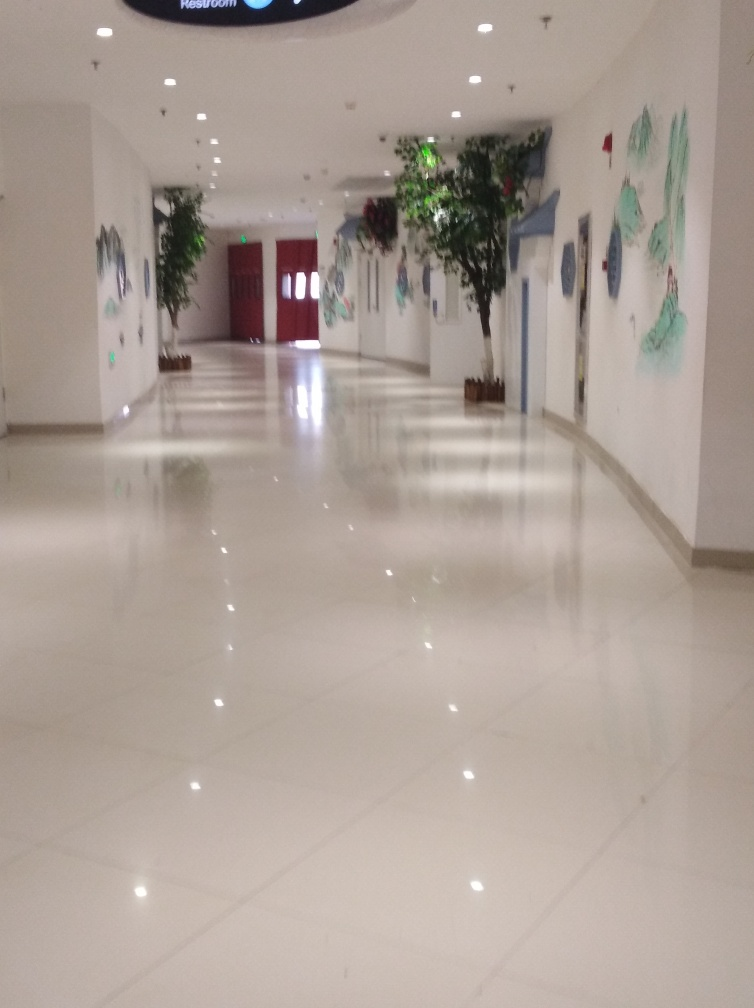What mood does this image evoke and why? The image evokes a sense of calmness and serenity, likely due to the clean lines, the well-arranged indoor plants, and the softly diffused lighting. The open space suggests a quiet and peaceful environment, possibly in a place of rest or an art-focused setting. 